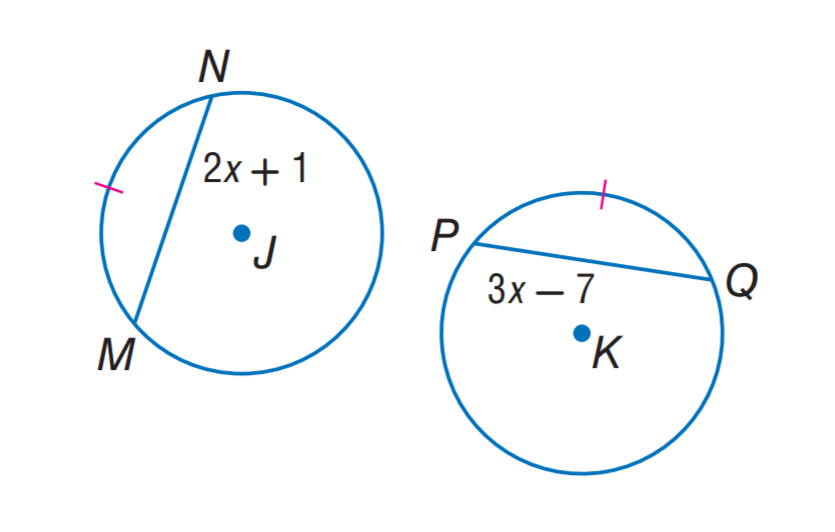Question: \odot J \cong \odot K and \widehat M N \cong \widehat P Q. Find P Q.
Choices:
A. 7
B. 17
C. 21
D. 24
Answer with the letter. Answer: B 